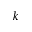Convert formula to latex. <formula><loc_0><loc_0><loc_500><loc_500>k</formula> 